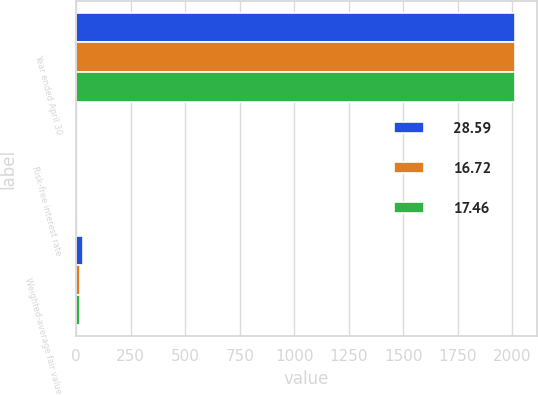<chart> <loc_0><loc_0><loc_500><loc_500><stacked_bar_chart><ecel><fcel>Year ended April 30<fcel>Risk-free interest rate<fcel>Weighted-average fair value<nl><fcel>28.59<fcel>2014<fcel>0.61<fcel>28.59<nl><fcel>16.72<fcel>2013<fcel>0.4<fcel>16.72<nl><fcel>17.46<fcel>2012<fcel>0.75<fcel>17.46<nl></chart> 